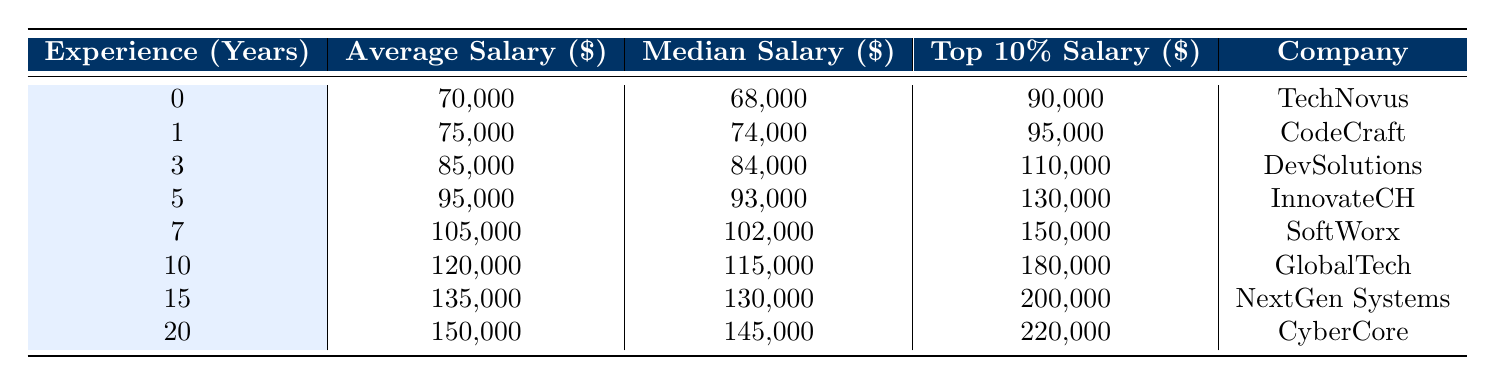What is the average salary for a software engineer with 3 years of experience? According to the table, the average salary for a software engineer with 3 years of experience is 85,000.
Answer: 85,000 What is the top 10 percent salary for a software engineer with 10 years of experience? The table indicates that the top 10 percent salary for a software engineer with 10 years of experience is 180,000.
Answer: 180,000 Is the median salary for a software engineer with 5 years of experience greater than 90,000? The median salary for a software engineer with 5 years of experience is 93,000, which is greater than 90,000. Therefore, the answer is yes.
Answer: Yes What is the difference between the average salary for a software engineer with 1 year of experience and the average salary for one with 5 years? The average salary for 1 year is 75,000, and for 5 years it is 95,000. The difference is 95,000 - 75,000 = 20,000.
Answer: 20,000 Is the top 10 percent salary for software engineers with 15 years of experience lower than the average salary for those with 20 years? The top 10 percent salary for 15 years is 200,000, while the average for 20 years is 150,000. Since 200,000 is not lower than 150,000, the answer is no.
Answer: No What is the average salary increase when comparing software engineers with 10 years of experience to those with 7 years of experience? The average salary for 10 years is 120,000, and for 7 years it is 105,000. The increase is 120,000 - 105,000 = 15,000.
Answer: 15,000 How much more does a software engineer with 20 years of experience earn on average compared to one with no experience? The average salary for a software engineer with 20 years of experience is 150,000, while with no experience it is 70,000. The difference is 150,000 - 70,000 = 80,000.
Answer: 80,000 What is the median salary for a software engineer with 0 years of experience? The table shows that the median salary for a software engineer with 0 years of experience is 68,000.
Answer: 68,000 What is the average of the median salaries for all the experience levels listed? The median salaries are 68,000, 74,000, 84,000, 93,000, 102,000, 115,000, 130,000, and 145,000. The sum is 68,000 + 74,000 + 84,000 + 93,000 + 102,000 + 115,000 + 130,000 + 145,000 =  811,000. There are 8 values, so the average is 811,000 / 8 = 101,375.
Answer: 101,375 